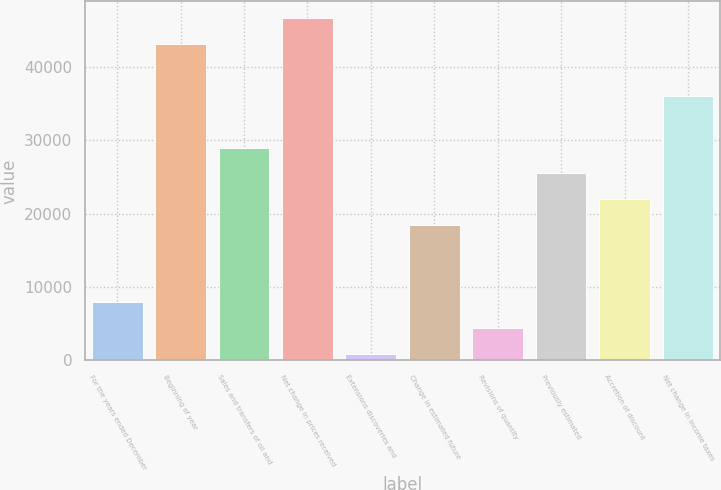Convert chart. <chart><loc_0><loc_0><loc_500><loc_500><bar_chart><fcel>For the years ended December<fcel>Beginning of year<fcel>Sales and transfers of oil and<fcel>Net change in prices received<fcel>Extensions discoveries and<fcel>Change in estimated future<fcel>Revisions of quantity<fcel>Previously estimated<fcel>Accretion of discount<fcel>Net change in income taxes<nl><fcel>7899.4<fcel>43126.4<fcel>29035.6<fcel>46649.1<fcel>854<fcel>18467.5<fcel>4376.7<fcel>25512.9<fcel>21990.2<fcel>36081<nl></chart> 